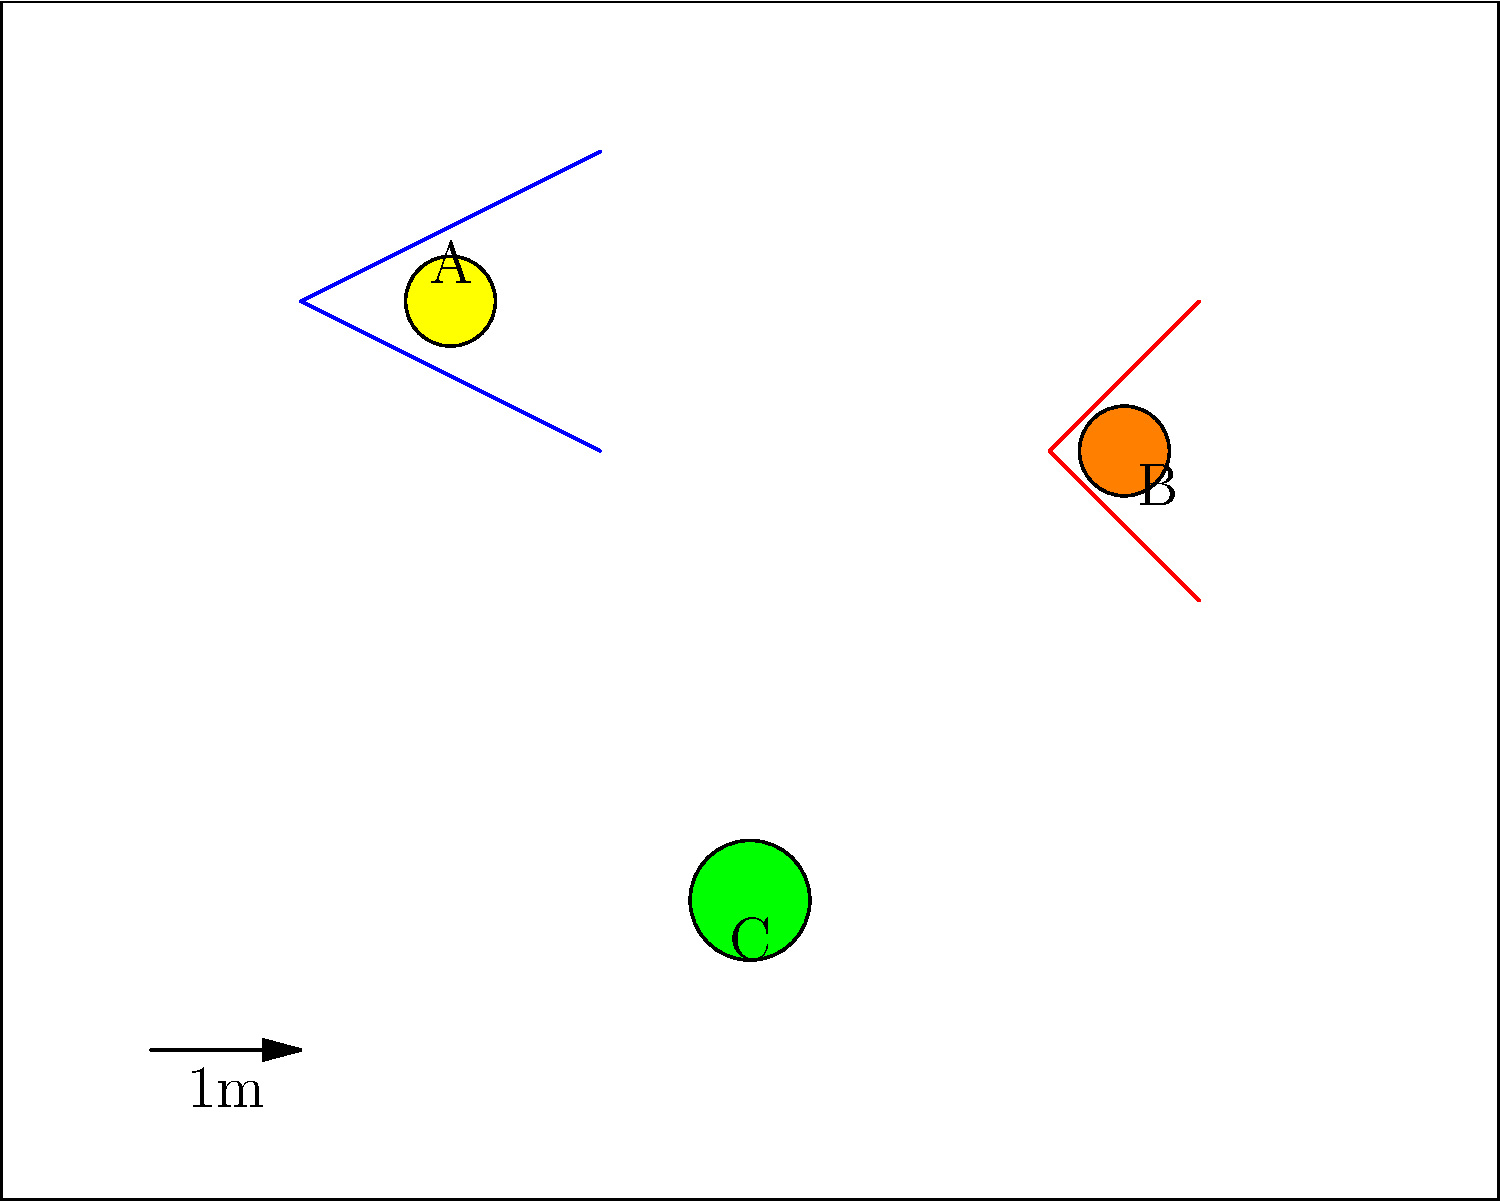In the laboratory setup illustration, three potential safety hazards are marked as A, B, and C. Based on their visual representations, identify which hazard is most likely associated with flammable materials and explain why this is crucial information for a customer relations representative in the chemicals industry. To answer this question, let's analyze each hazard:

1. Hazard A (blue symbol with yellow circle):
   This symbol typically represents electrical hazards or high voltage.

2. Hazard B (red symbol with orange circle):
   This symbol commonly indicates flammable materials or fire hazards.

3. Hazard C (green circle):
   This could represent various hazards, such as biological or chemical substances.

The hazard most likely associated with flammable materials is B, due to its red color and flame-like shape.

For a customer relations representative in the chemicals industry, this information is crucial because:

1. Safety awareness: Understanding potential hazards helps in communicating safety protocols to customers.

2. Product knowledge: Identifying flammable materials is essential for proper handling, storage, and transportation of chemical products.

3. Risk management: Awareness of fire hazards allows for better risk assessment and mitigation strategies when dealing with customer inquiries or complaints.

4. Regulatory compliance: Knowledge of hazard symbols ensures compliance with safety regulations and standards in the chemicals industry.

5. Customer education: The ability to explain hazard symbols helps in educating customers about proper product usage and safety measures.

6. Emergency response: In case of incidents, understanding hazard symbols aids in providing accurate information to emergency responders.

7. Liability protection: Proper identification and communication of hazards can help protect the company from potential legal issues.
Answer: Hazard B (flammable materials) 